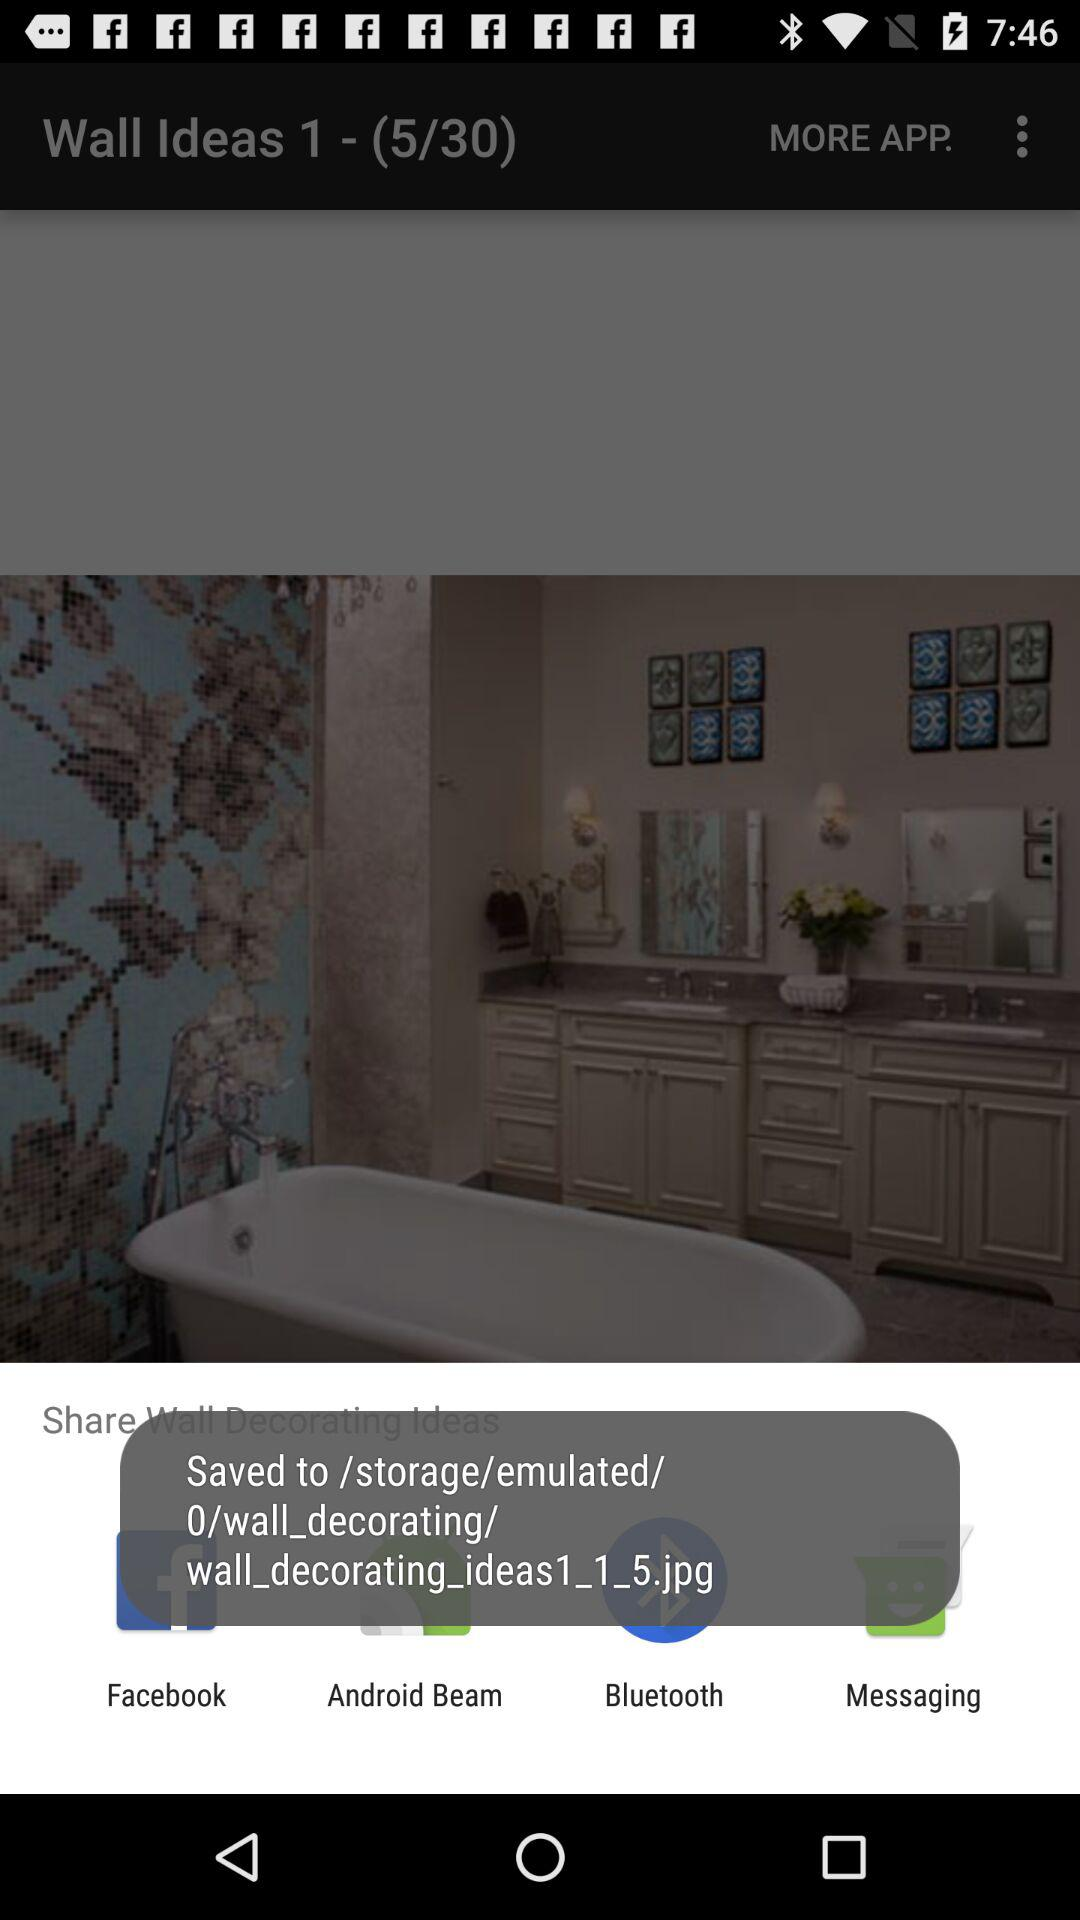What are the options available for sharing? The options are "Facebook", "Android Beam", "Bluetooth", and "Messaging". 